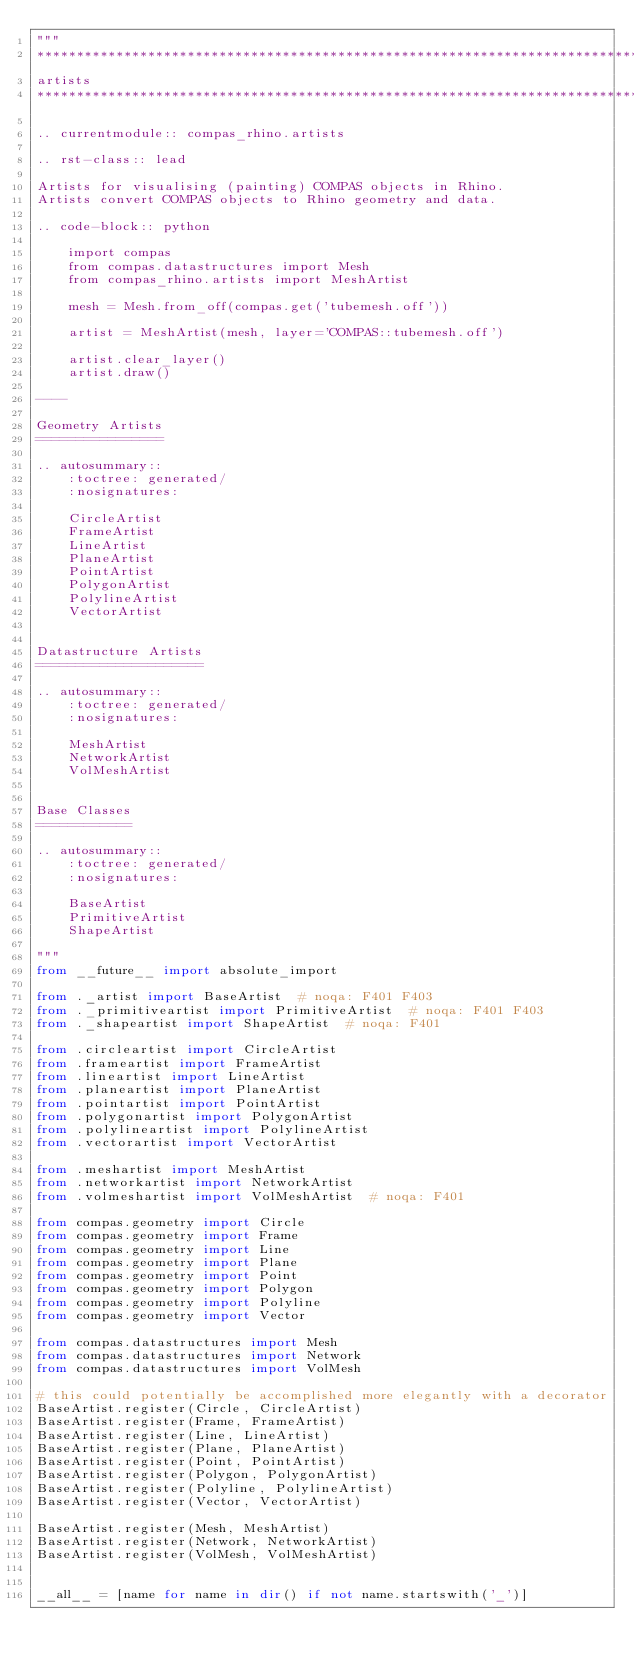<code> <loc_0><loc_0><loc_500><loc_500><_Python_>"""
********************************************************************************
artists
********************************************************************************

.. currentmodule:: compas_rhino.artists

.. rst-class:: lead

Artists for visualising (painting) COMPAS objects in Rhino.
Artists convert COMPAS objects to Rhino geometry and data.

.. code-block:: python

    import compas
    from compas.datastructures import Mesh
    from compas_rhino.artists import MeshArtist

    mesh = Mesh.from_off(compas.get('tubemesh.off'))

    artist = MeshArtist(mesh, layer='COMPAS::tubemesh.off')

    artist.clear_layer()
    artist.draw()

----

Geometry Artists
================

.. autosummary::
    :toctree: generated/
    :nosignatures:

    CircleArtist
    FrameArtist
    LineArtist
    PlaneArtist
    PointArtist
    PolygonArtist
    PolylineArtist
    VectorArtist


Datastructure Artists
=====================

.. autosummary::
    :toctree: generated/
    :nosignatures:

    MeshArtist
    NetworkArtist
    VolMeshArtist


Base Classes
============

.. autosummary::
    :toctree: generated/
    :nosignatures:

    BaseArtist
    PrimitiveArtist
    ShapeArtist

"""
from __future__ import absolute_import

from ._artist import BaseArtist  # noqa: F401 F403
from ._primitiveartist import PrimitiveArtist  # noqa: F401 F403
from ._shapeartist import ShapeArtist  # noqa: F401

from .circleartist import CircleArtist
from .frameartist import FrameArtist
from .lineartist import LineArtist
from .planeartist import PlaneArtist
from .pointartist import PointArtist
from .polygonartist import PolygonArtist
from .polylineartist import PolylineArtist
from .vectorartist import VectorArtist

from .meshartist import MeshArtist
from .networkartist import NetworkArtist
from .volmeshartist import VolMeshArtist  # noqa: F401

from compas.geometry import Circle
from compas.geometry import Frame
from compas.geometry import Line
from compas.geometry import Plane
from compas.geometry import Point
from compas.geometry import Polygon
from compas.geometry import Polyline
from compas.geometry import Vector

from compas.datastructures import Mesh
from compas.datastructures import Network
from compas.datastructures import VolMesh

# this could potentially be accomplished more elegantly with a decorator
BaseArtist.register(Circle, CircleArtist)
BaseArtist.register(Frame, FrameArtist)
BaseArtist.register(Line, LineArtist)
BaseArtist.register(Plane, PlaneArtist)
BaseArtist.register(Point, PointArtist)
BaseArtist.register(Polygon, PolygonArtist)
BaseArtist.register(Polyline, PolylineArtist)
BaseArtist.register(Vector, VectorArtist)

BaseArtist.register(Mesh, MeshArtist)
BaseArtist.register(Network, NetworkArtist)
BaseArtist.register(VolMesh, VolMeshArtist)


__all__ = [name for name in dir() if not name.startswith('_')]
</code> 